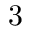<formula> <loc_0><loc_0><loc_500><loc_500>3</formula> 